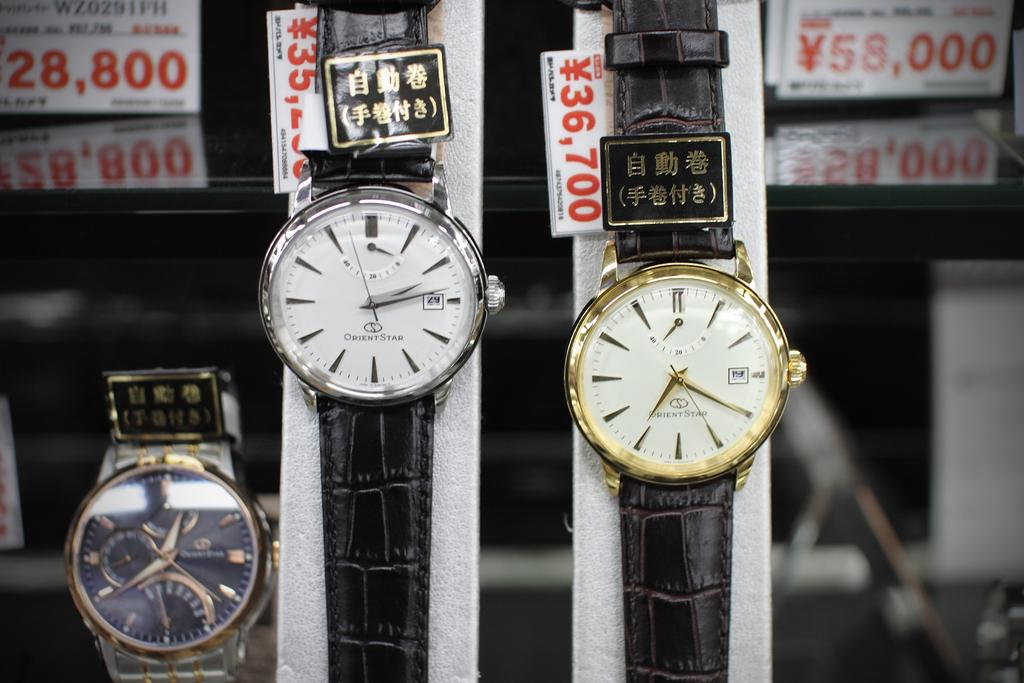<image>
Provide a brief description of the given image. One watch in this store display sells for 28,800 yen. 